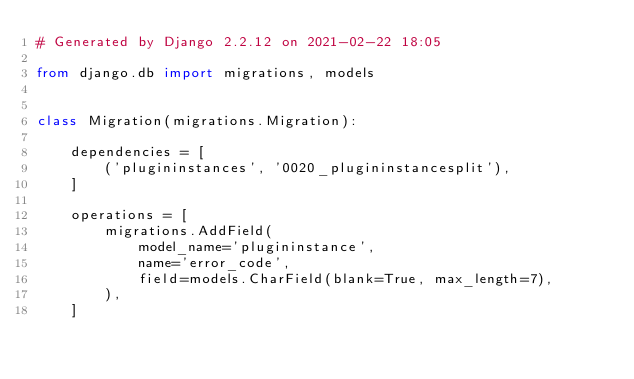Convert code to text. <code><loc_0><loc_0><loc_500><loc_500><_Python_># Generated by Django 2.2.12 on 2021-02-22 18:05

from django.db import migrations, models


class Migration(migrations.Migration):

    dependencies = [
        ('plugininstances', '0020_plugininstancesplit'),
    ]

    operations = [
        migrations.AddField(
            model_name='plugininstance',
            name='error_code',
            field=models.CharField(blank=True, max_length=7),
        ),
    ]
</code> 